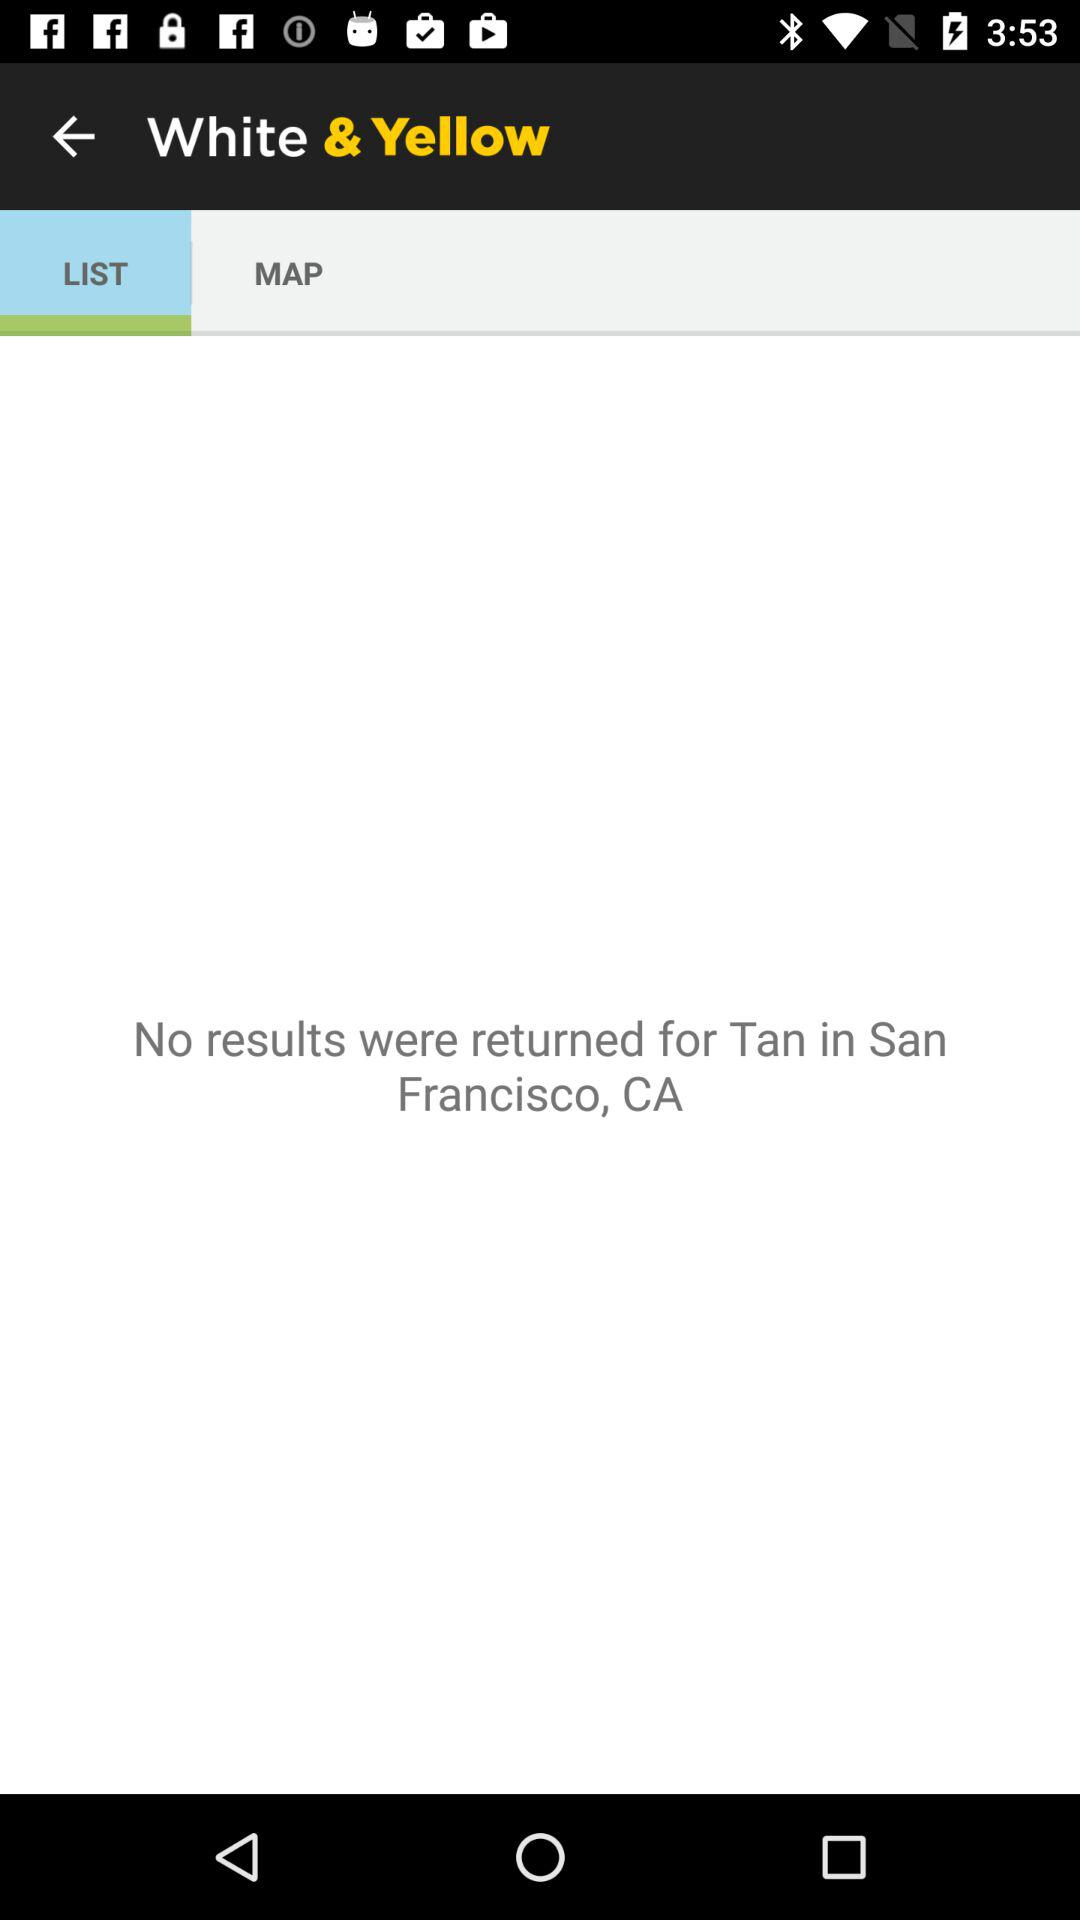Which tab has been selected? The selected tab is "LIST". 